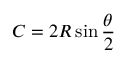Convert formula to latex. <formula><loc_0><loc_0><loc_500><loc_500>C = 2 R \sin { \frac { \theta } { 2 } }</formula> 